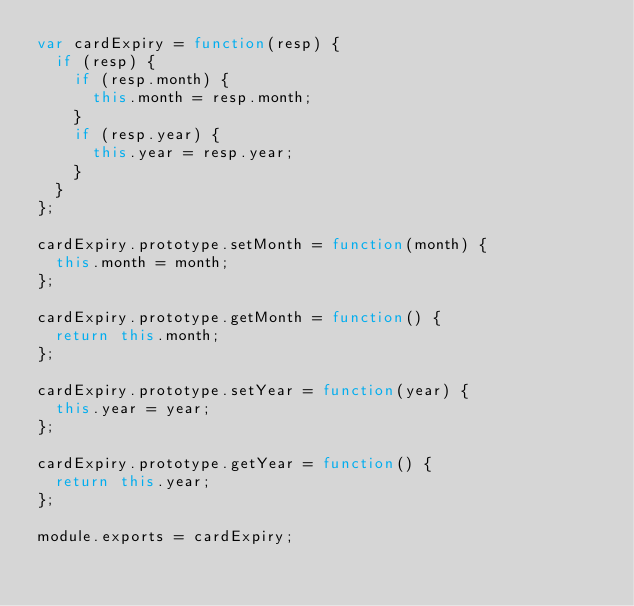Convert code to text. <code><loc_0><loc_0><loc_500><loc_500><_JavaScript_>var cardExpiry = function(resp) {
	if (resp) {
		if (resp.month) {
			this.month = resp.month;
		}
		if (resp.year) {
			this.year = resp.year;
		}
	}
};

cardExpiry.prototype.setMonth = function(month) {
	this.month = month;
};

cardExpiry.prototype.getMonth = function() {
	return this.month;
};

cardExpiry.prototype.setYear = function(year) {
	this.year = year;
};

cardExpiry.prototype.getYear = function() {
	return this.year;
};

module.exports = cardExpiry;</code> 